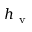Convert formula to latex. <formula><loc_0><loc_0><loc_500><loc_500>h _ { v }</formula> 